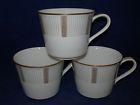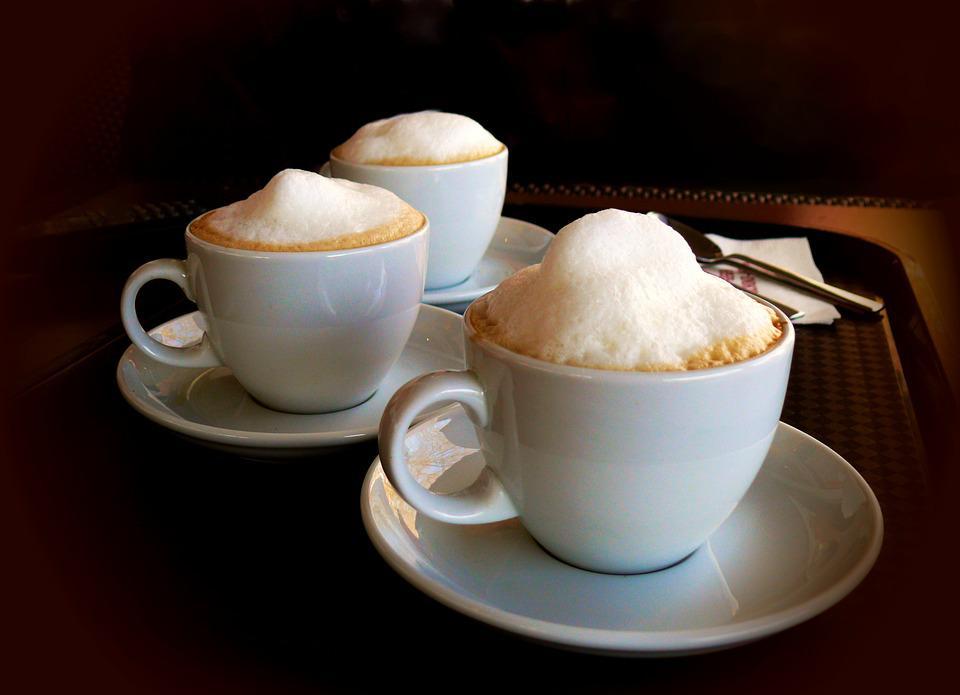The first image is the image on the left, the second image is the image on the right. For the images displayed, is the sentence "The right image has three empty white coffee cups." factually correct? Answer yes or no. No. The first image is the image on the left, the second image is the image on the right. Assess this claim about the two images: "There are 3 white coffee cups and saucers". Correct or not? Answer yes or no. Yes. 